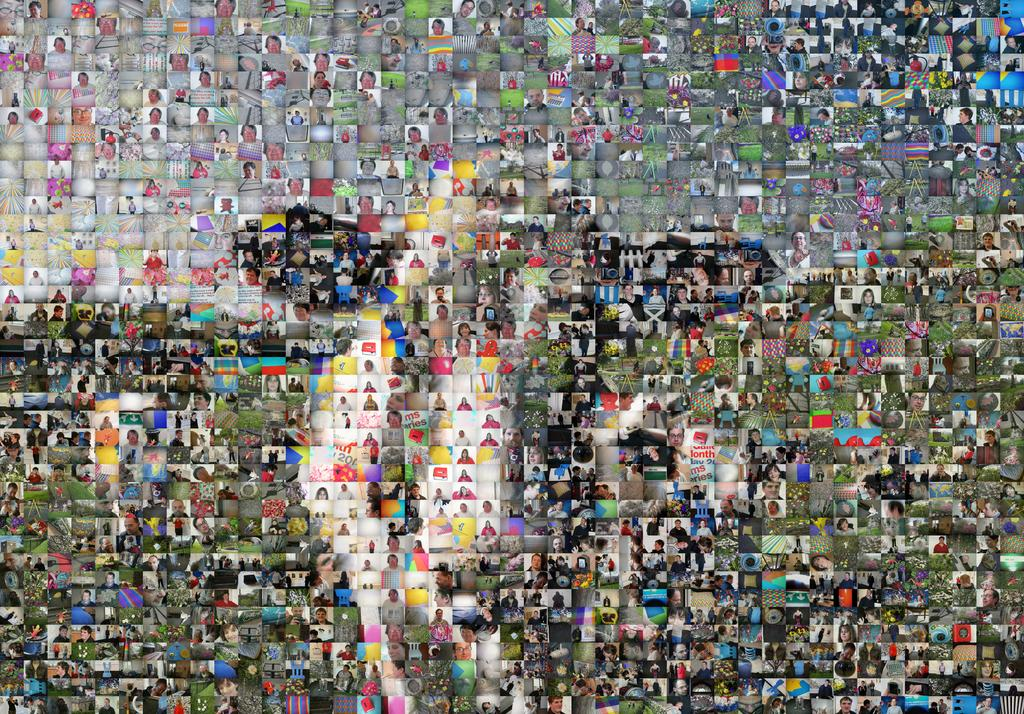What is the main subject of the image? The main subject of the image is a group of people. What type of environment is depicted in the image? The image shows grass, trees, and buildings, suggesting an outdoor setting. Are there any living creatures besides humans in the image? Yes, there are animals in the image. What type of competition is taking place between the governor and the women in the image? There is no governor or women present in the image, and therefore no such competition can be observed. 